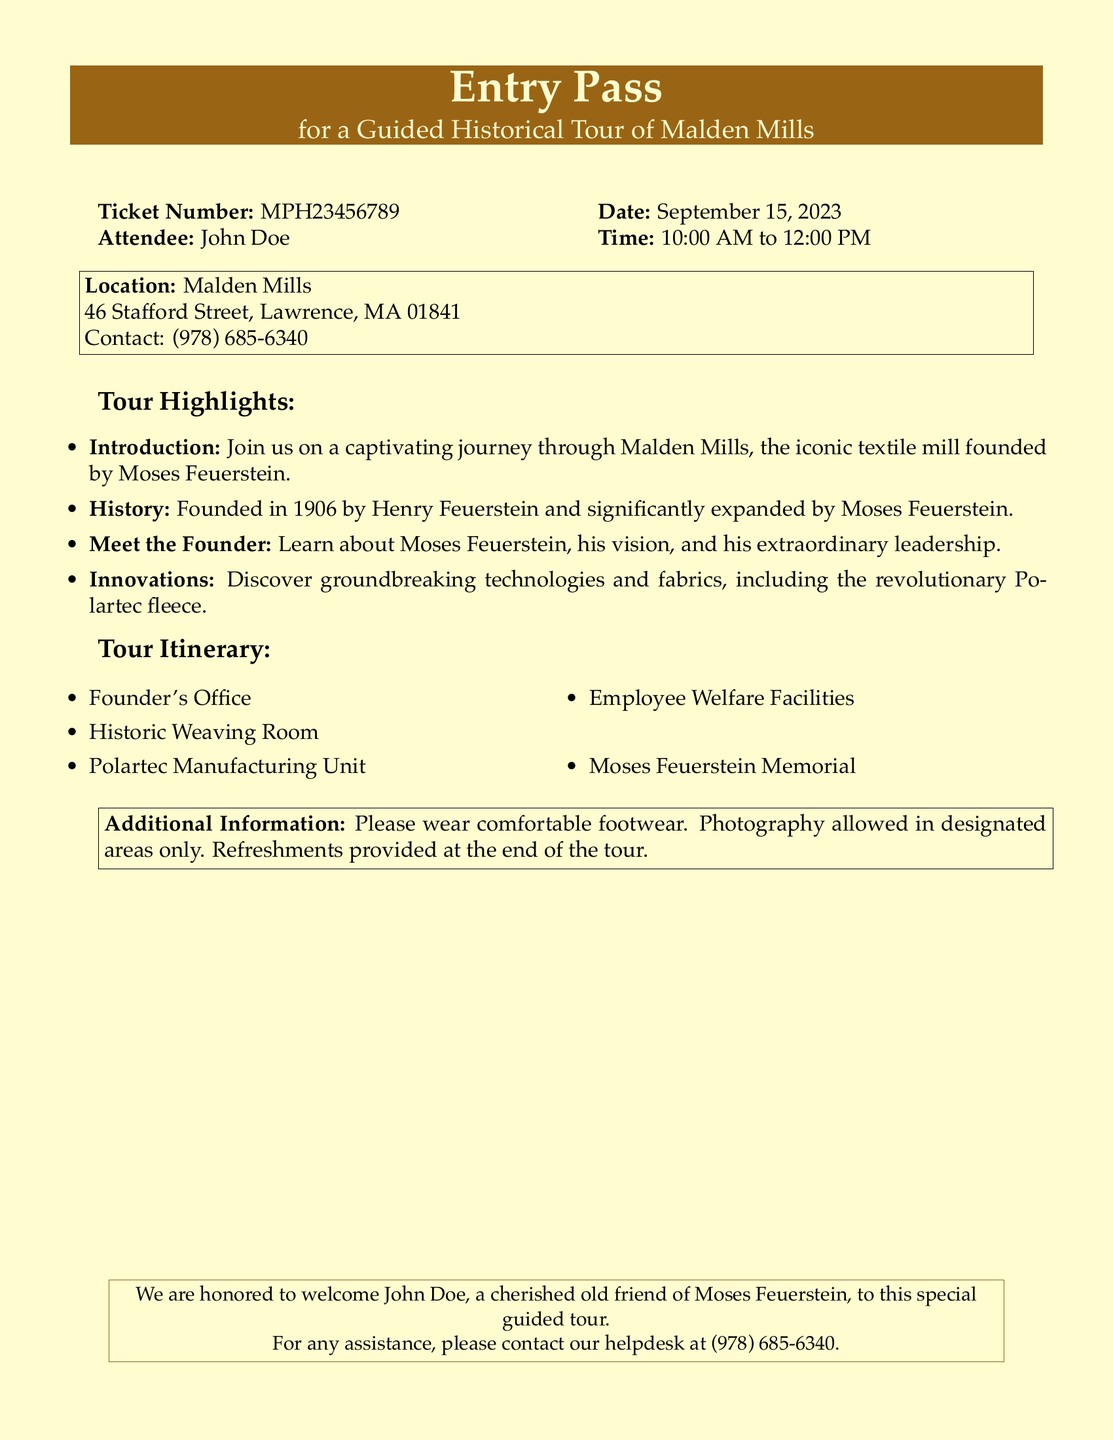What is the ticket number? The ticket number is specified in the document, which is MPH23456789.
Answer: MPH23456789 Who is the attendee? The document lists John Doe as the attendee for the guided tour.
Answer: John Doe What is the date of the tour? The date of the tour is clearly mentioned as September 15, 2023.
Answer: September 15, 2023 Where is the location of the tour? The location is provided in the document, which is Malden Mills, 46 Stafford Street, Lawrence, MA 01841.
Answer: Malden Mills, 46 Stafford Street, Lawrence, MA 01841 What are the tour highlights? The highlights include an introduction to Malden Mills, history, meeting the founder, and discovering innovations.
Answer: Introduction, history, meeting the founder, innovations What time does the tour start? The start time of the tour is specified as 10:00 AM.
Answer: 10:00 AM What should attendees wear? The document advises attendees to wear comfortable footwear.
Answer: Comfortable footwear How long is the tour scheduled to last? The scheduled duration of the tour is from 10:00 AM to 12:00 PM, which is 2 hours.
Answer: 2 hours Who founded Malden Mills? The document states that Malden Mills was founded by Henry Feuerstein.
Answer: Henry Feuerstein 